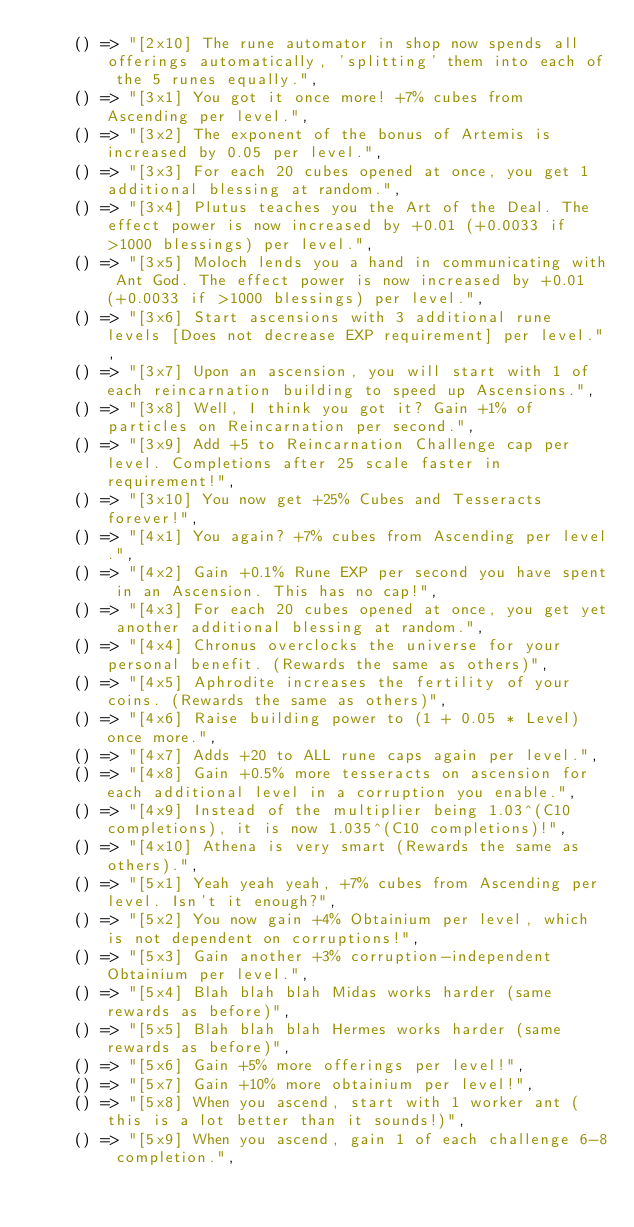<code> <loc_0><loc_0><loc_500><loc_500><_JavaScript_>    () => "[2x10] The rune automator in shop now spends all offerings automatically, 'splitting' them into each of the 5 runes equally.",
    () => "[3x1] You got it once more! +7% cubes from Ascending per level.",
    () => "[3x2] The exponent of the bonus of Artemis is increased by 0.05 per level.",
    () => "[3x3] For each 20 cubes opened at once, you get 1 additional blessing at random.",
    () => "[3x4] Plutus teaches you the Art of the Deal. The effect power is now increased by +0.01 (+0.0033 if >1000 blessings) per level.",
    () => "[3x5] Moloch lends you a hand in communicating with Ant God. The effect power is now increased by +0.01 (+0.0033 if >1000 blessings) per level.",
    () => "[3x6] Start ascensions with 3 additional rune levels [Does not decrease EXP requirement] per level.",
    () => "[3x7] Upon an ascension, you will start with 1 of each reincarnation building to speed up Ascensions.",
    () => "[3x8] Well, I think you got it? Gain +1% of particles on Reincarnation per second.",
    () => "[3x9] Add +5 to Reincarnation Challenge cap per level. Completions after 25 scale faster in requirement!",
    () => "[3x10] You now get +25% Cubes and Tesseracts forever!",
    () => "[4x1] You again? +7% cubes from Ascending per level.",
    () => "[4x2] Gain +0.1% Rune EXP per second you have spent in an Ascension. This has no cap!",
    () => "[4x3] For each 20 cubes opened at once, you get yet another additional blessing at random.",
    () => "[4x4] Chronus overclocks the universe for your personal benefit. (Rewards the same as others)",
    () => "[4x5] Aphrodite increases the fertility of your coins. (Rewards the same as others)",
    () => "[4x6] Raise building power to (1 + 0.05 * Level) once more.",
    () => "[4x7] Adds +20 to ALL rune caps again per level.",
    () => "[4x8] Gain +0.5% more tesseracts on ascension for each additional level in a corruption you enable.",
    () => "[4x9] Instead of the multiplier being 1.03^(C10 completions), it is now 1.035^(C10 completions)!",
    () => "[4x10] Athena is very smart (Rewards the same as others).",
    () => "[5x1] Yeah yeah yeah, +7% cubes from Ascending per level. Isn't it enough?",
    () => "[5x2] You now gain +4% Obtainium per level, which is not dependent on corruptions!",
    () => "[5x3] Gain another +3% corruption-independent Obtainium per level.",
    () => "[5x4] Blah blah blah Midas works harder (same rewards as before)",
    () => "[5x5] Blah blah blah Hermes works harder (same rewards as before)",
    () => "[5x6] Gain +5% more offerings per level!",
    () => "[5x7] Gain +10% more obtainium per level!",
    () => "[5x8] When you ascend, start with 1 worker ant (this is a lot better than it sounds!)",
    () => "[5x9] When you ascend, gain 1 of each challenge 6-8 completion.",</code> 